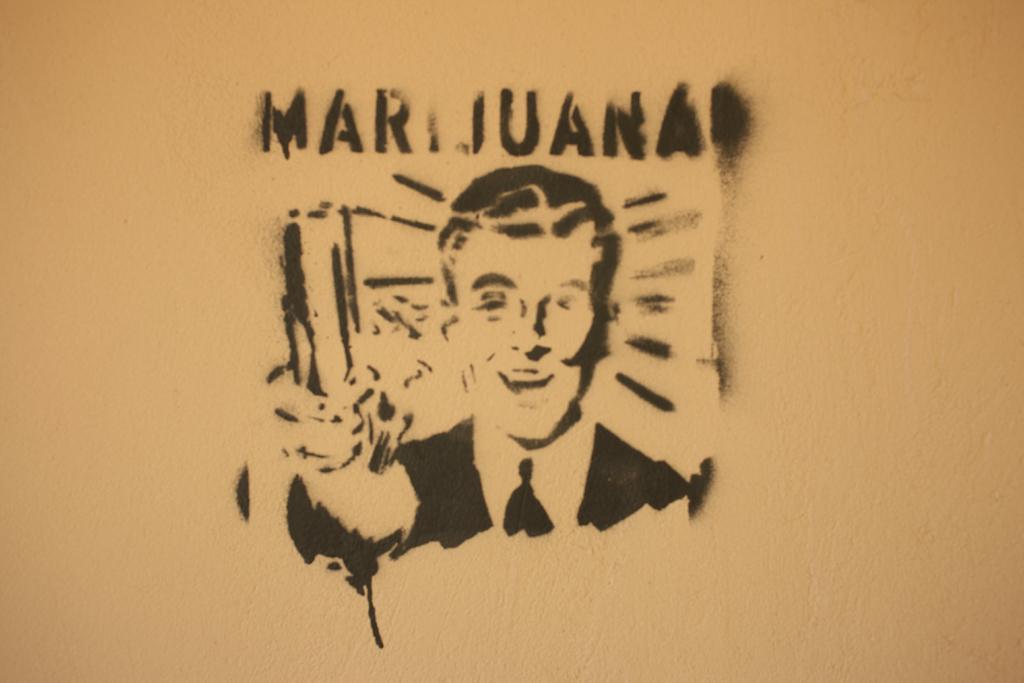How would you summarize this image in a sentence or two? In this picture I can see the design of a person on the wall. At the top I can see the name of the person. 